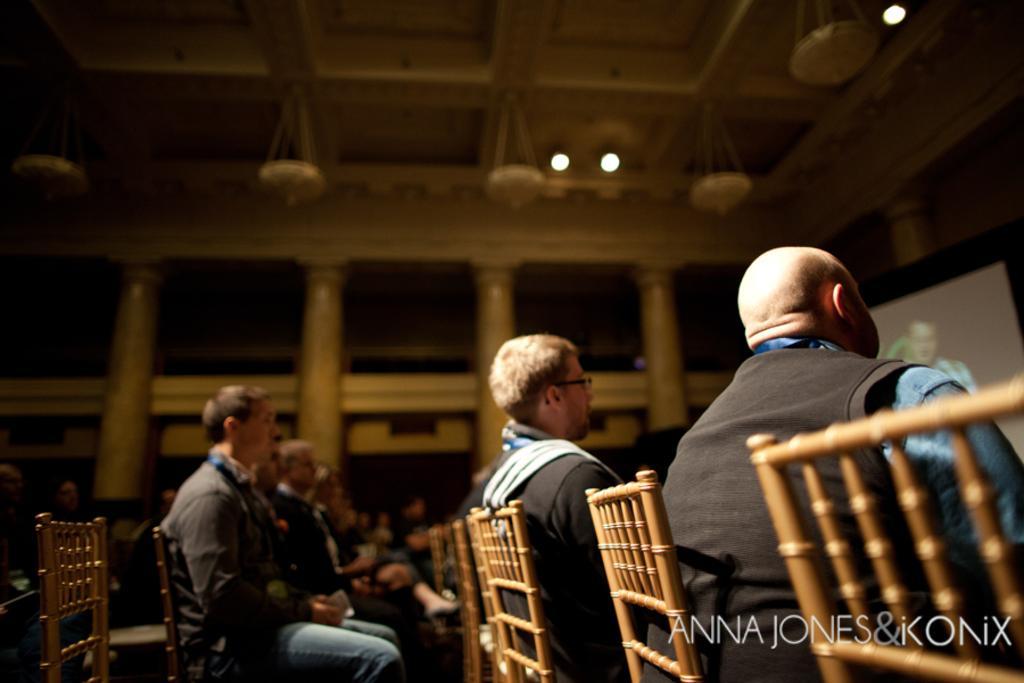How would you summarize this image in a sentence or two? In the center of the image we can see some persons are sitting on a chair. At the top of the image we can see roof, lights, pillars, walls are there. On the right side of the image screen is present. 